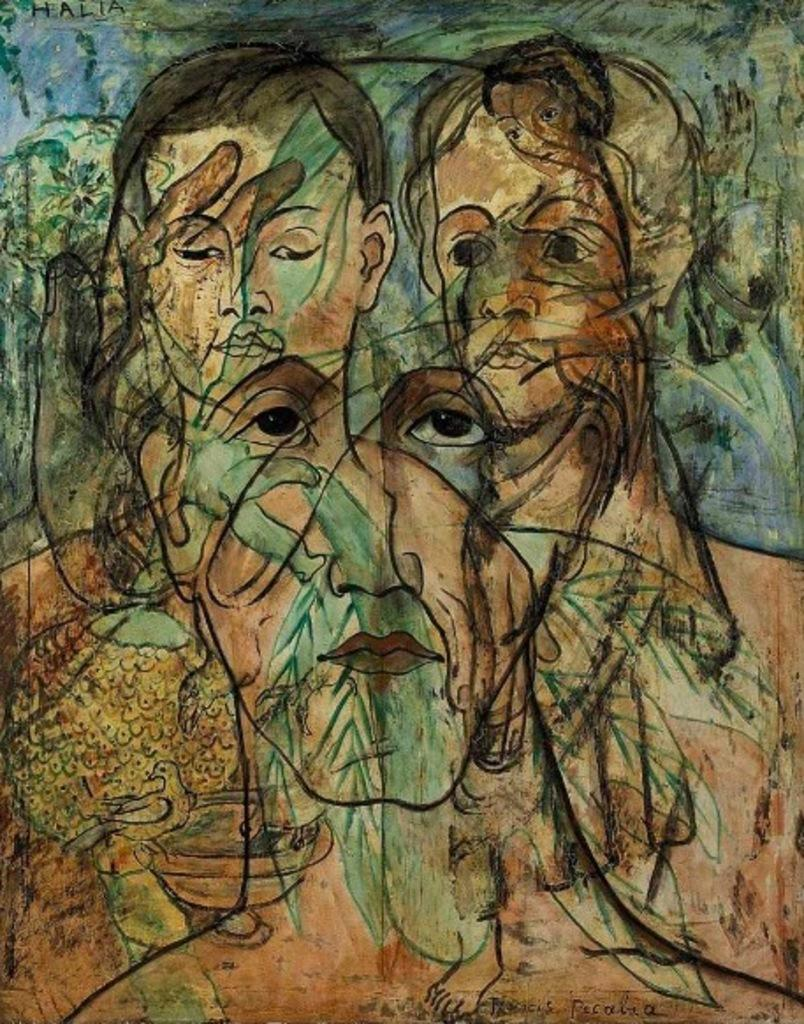What type of artwork is depicted in the image? The image is a painting. What subjects are featured in the painting? There are human faces in the painting. What is the plot of the story being told in the painting? The painting is not a story, so there is no plot to describe. 